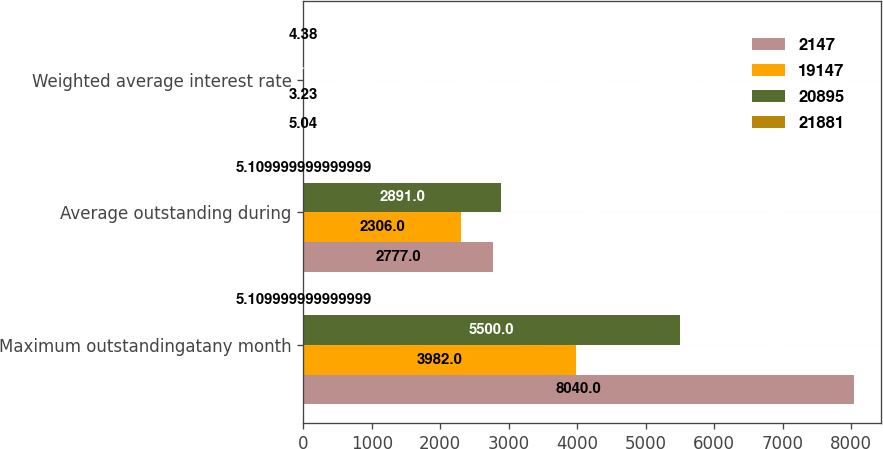Convert chart. <chart><loc_0><loc_0><loc_500><loc_500><stacked_bar_chart><ecel><fcel>Maximum outstandingatany month<fcel>Average outstanding during<fcel>Weighted average interest rate<nl><fcel>2147<fcel>8040<fcel>2777<fcel>5.04<nl><fcel>19147<fcel>3982<fcel>2306<fcel>3.23<nl><fcel>20895<fcel>5500<fcel>2891<fcel>1.4<nl><fcel>21881<fcel>5.11<fcel>5.11<fcel>4.38<nl></chart> 